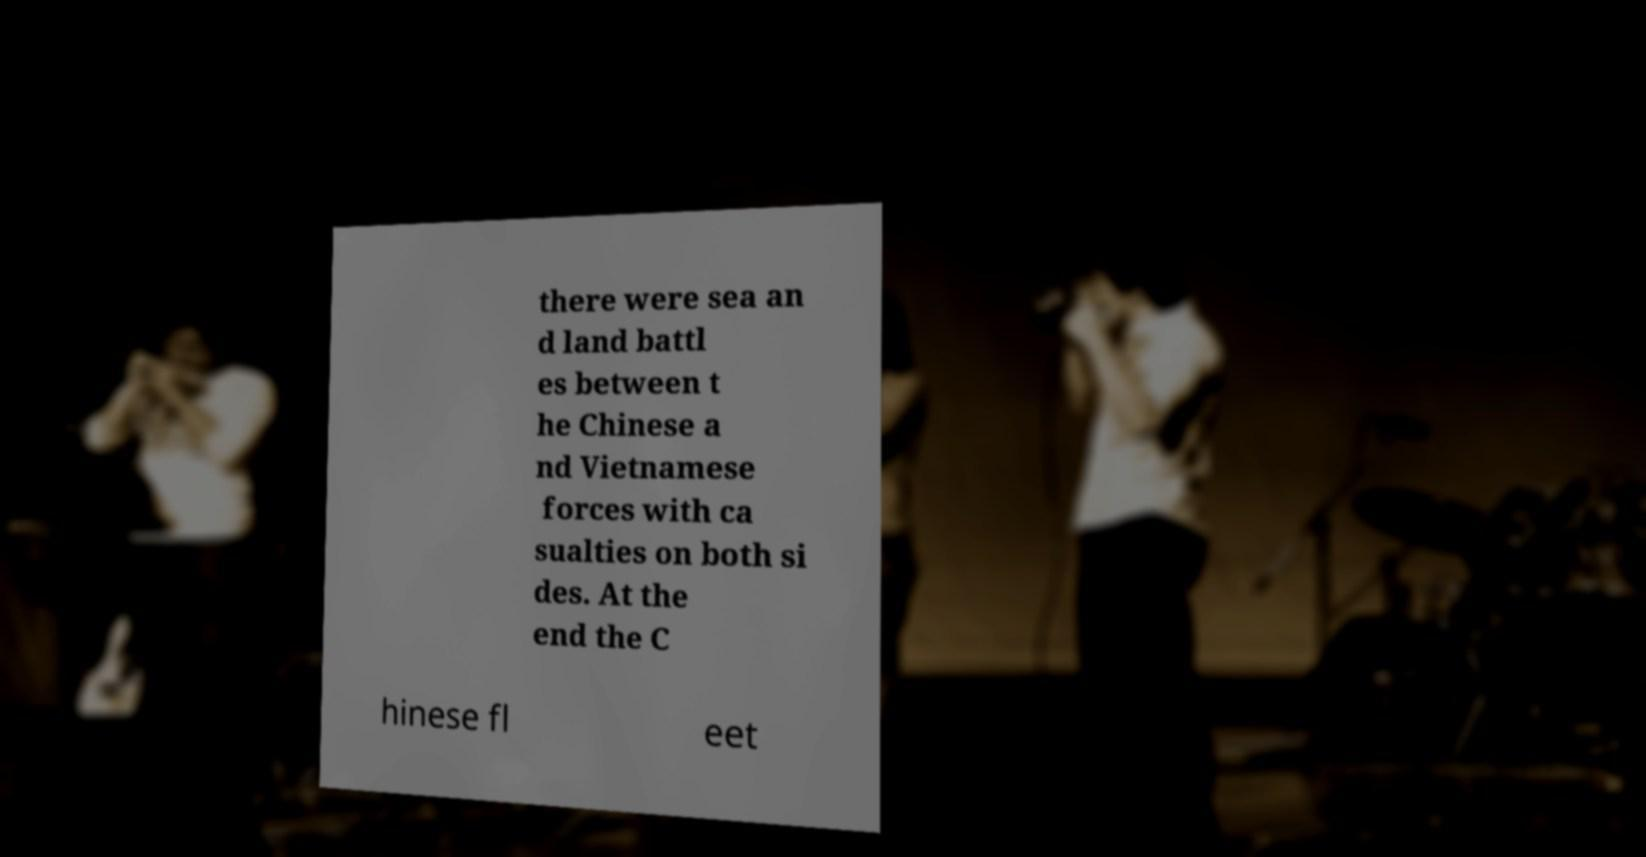Can you read and provide the text displayed in the image?This photo seems to have some interesting text. Can you extract and type it out for me? there were sea an d land battl es between t he Chinese a nd Vietnamese forces with ca sualties on both si des. At the end the C hinese fl eet 